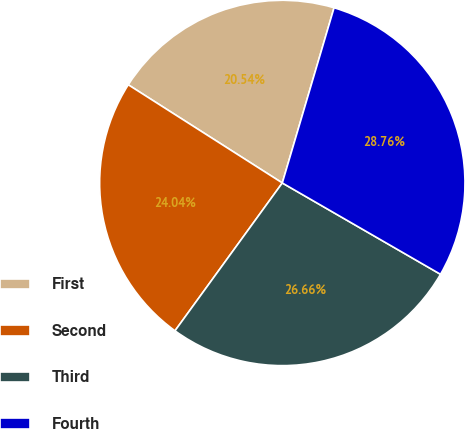Convert chart. <chart><loc_0><loc_0><loc_500><loc_500><pie_chart><fcel>First<fcel>Second<fcel>Third<fcel>Fourth<nl><fcel>20.54%<fcel>24.04%<fcel>26.66%<fcel>28.76%<nl></chart> 